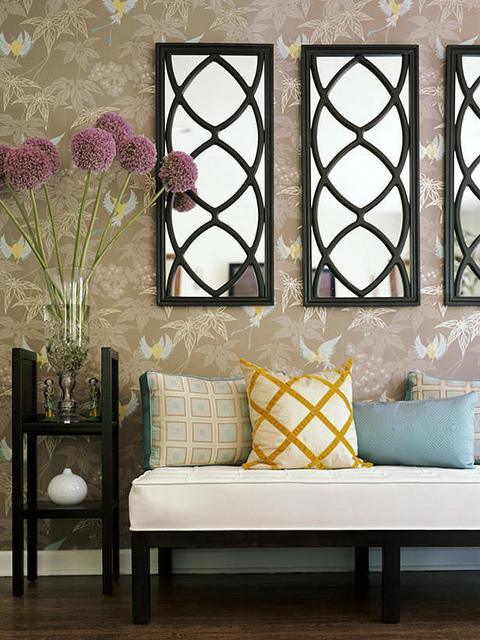Does the pillow in the middle share the same pattern as the windows?
Quick response, please. No. How many people are sitting on the couch?
Concise answer only. 0. What color are the flowers?
Concise answer only. Purple. 